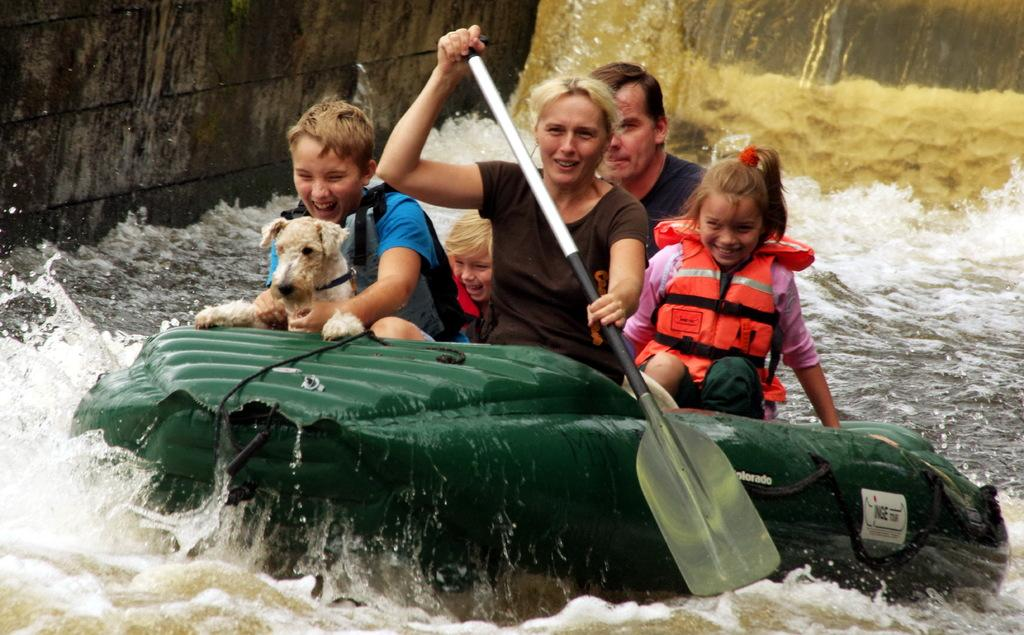What is the main subject of the image? The main subject of the image is a group of people. Can you describe the activity the group is engaged in? There is a dog on a boat in the image, and a woman is holding a paddle, suggesting they are boating or canoeing. What can be seen in the background of the image? There is water visible in the background of the image. What type of silk is draped over the calendar in the image? There is no calendar or silk present in the image. 